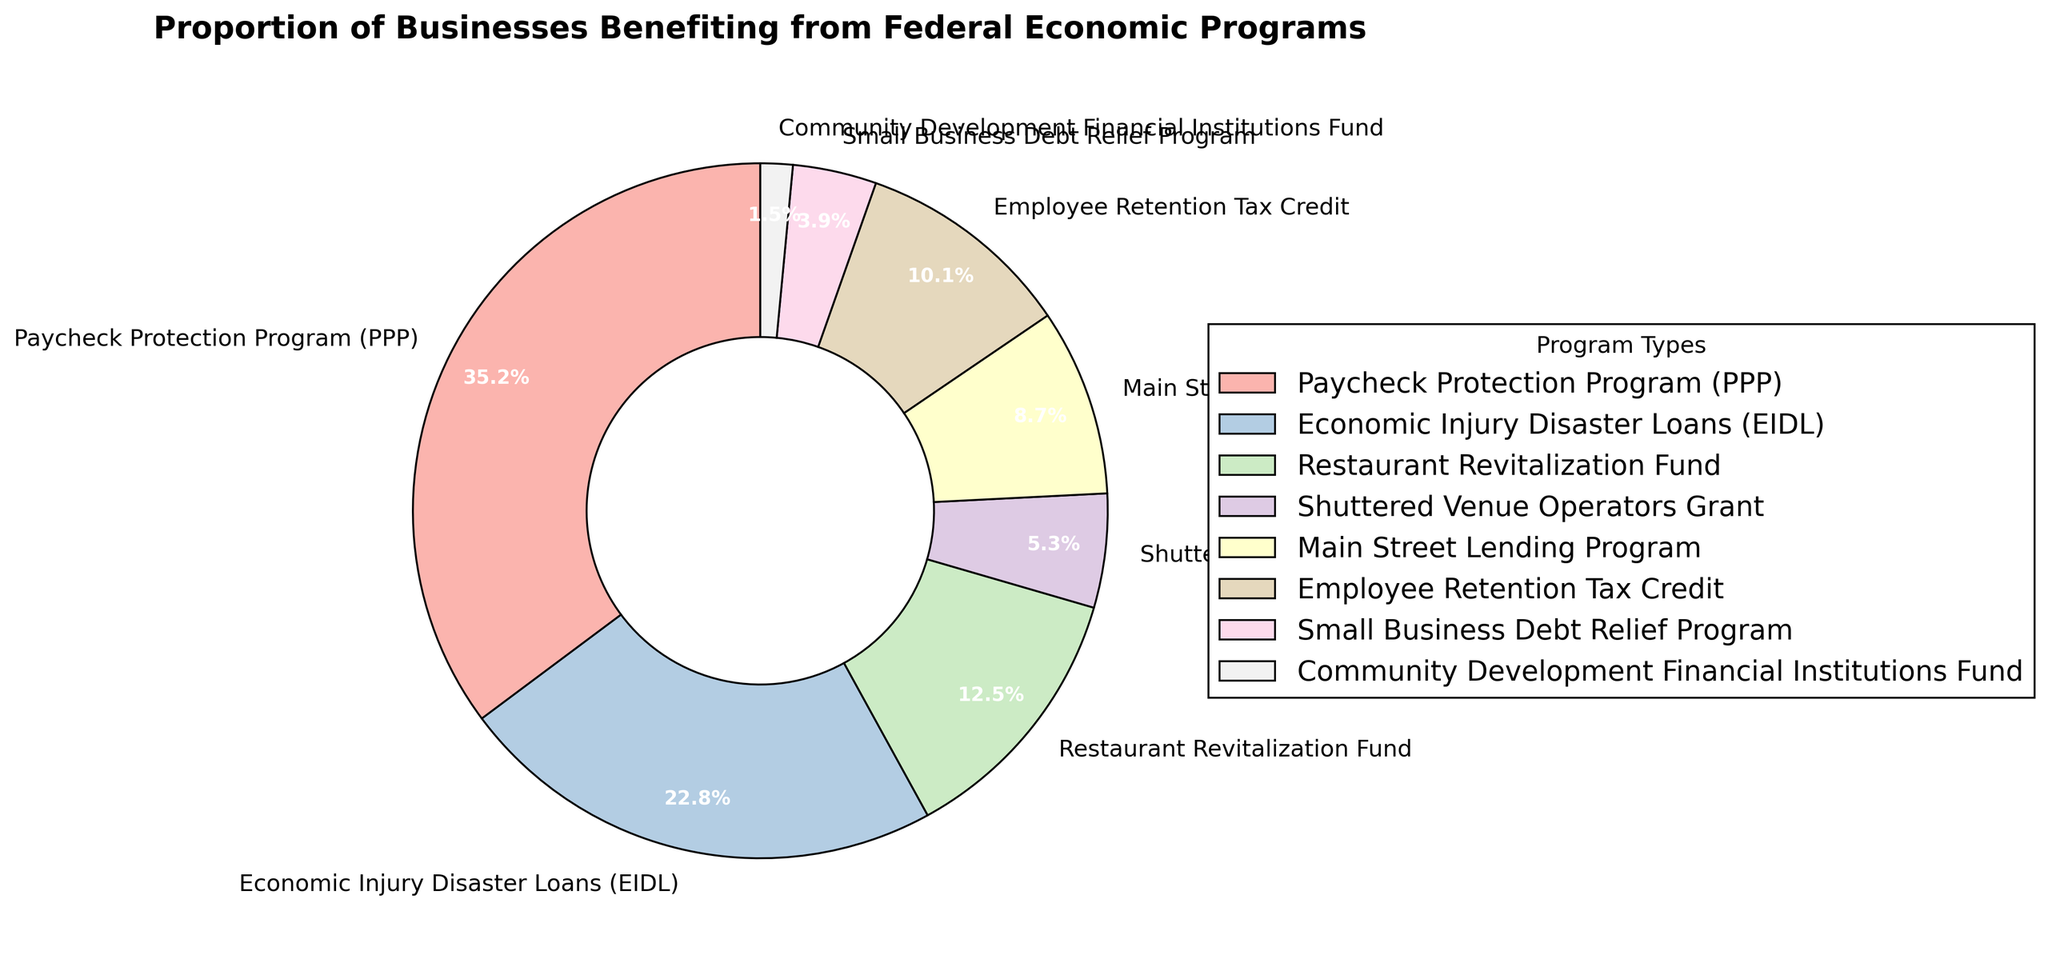what is the sum of percentages for the Paycheck Protection Program and the Economic Injury Disaster Loans? The Paycheck Protection Program has a percentage of 35.2% and the Economic Injury Disaster Loans have a percentage of 22.8%. Adding these together gives 35.2% + 22.8% = 58%.
Answer: 58% Which program provides more benefit to businesses, the Employee Retention Tax Credit or the Main Street Lending Program? The percentage for the Employee Retention Tax Credit is 10.1% and for the Main Street Lending Program, it is 8.7%. Since 10.1% is greater than 8.7%, the Employee Retention Tax Credit provides more benefit to businesses.
Answer: Employee Retention Tax Credit Which program has the smallest proportion of businesses benefiting from it? The Community Development Financial Institutions Fund has the smallest proportion at 1.5%.
Answer: Community Development Financial Institutions Fund What is the combined percentage of businesses benefiting from the Shuttered Venue Operators Grant and the Small Business Debt Relief Program? The Shuttered Venue Operators Grant has a percentage of 5.3% and the Small Business Debt Relief Program has 3.9%. Adding these together gives 5.3% + 3.9% = 9.2%.
Answer: 9.2% What's the difference in percentages between the Paycheck Protection Program and the Restaurant Revitalization Fund? The Paycheck Protection Program has a percentage of 35.2% and the Restaurant Revitalization Fund has a percentage of 12.5%. The difference is 35.2% - 12.5% = 22.7%.
Answer: 22.7% Which program accounts for the highest proportion of businesses benefiting from federal economic programs? The Paycheck Protection Program accounts for the highest proportion at 35.2%.
Answer: Paycheck Protection Program What is the average percentage of businesses benefiting from the Paycheck Protection Program, Economic Injury Disaster Loans, and the Restaurant Revitalization Fund? The percentages for these programs are 35.2%, 22.8%, and 12.5% respectively. The sum is 35.2% + 22.8% + 12.5% = 70.5%. The average is 70.5% / 3 ≈ 23.5%.
Answer: 23.5% Which program attracts more businesses, the Main Street Lending Program or the Shuttered Venue Operators Grant? The Main Street Lending Program has a percentage of 8.7% while the Shuttered Venue Operators Grant has a percentage of 5.3%. Since 8.7% is greater than 5.3%, the Main Street Lending Program attracts more businesses.
Answer: Main Street Lending Program What is the total percentage of businesses benefiting from all federal economic programs combined? Adding all percentages: 35.2% (PPP) + 22.8% (EIDL) + 12.5% (RRF) + 5.3% (SVOG) + 8.7% (MSLP) + 10.1% (ERTC) + 3.9% (SBDRP) + 1.5% (CDFI) = 100%.
Answer: 100% 